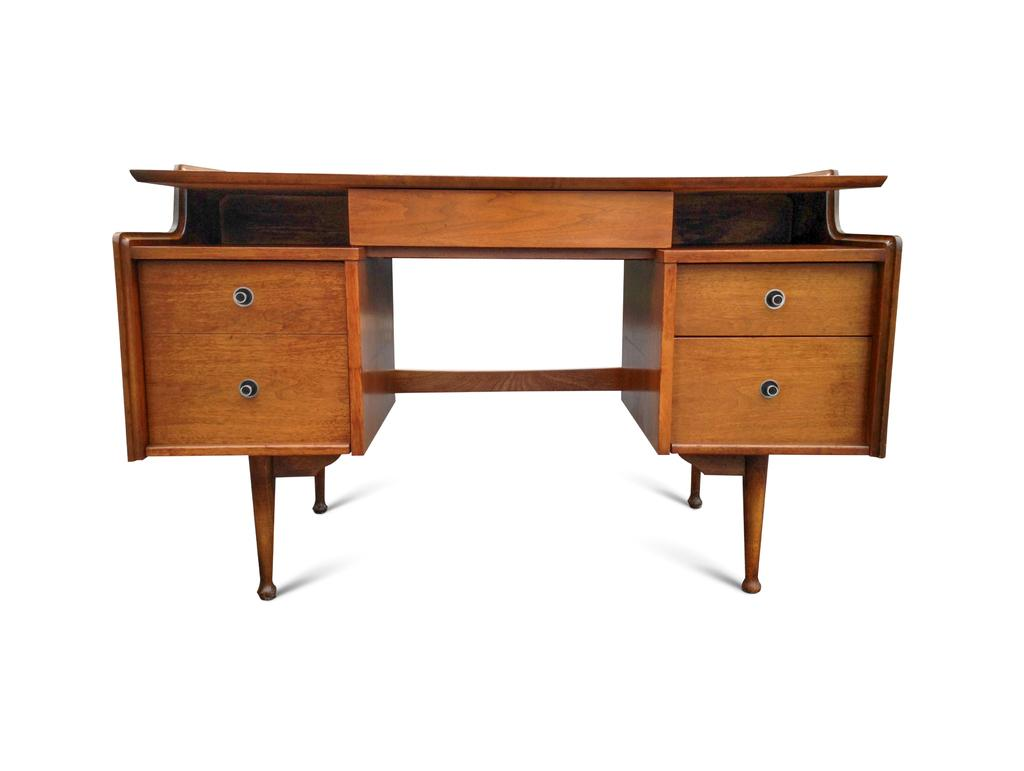What type of furniture is in the image? There is a wooden writing desk in the image. How many drawers does the writing desk have? The writing desk has four drawers. What color is the background of the image? The background of the image is white. What type of scale can be seen on the writing desk in the image? There is no scale present on the writing desk in the image. How many planes are visible in the image? There are no planes visible in the image; it features a wooden writing desk with four drawers and a white background. 